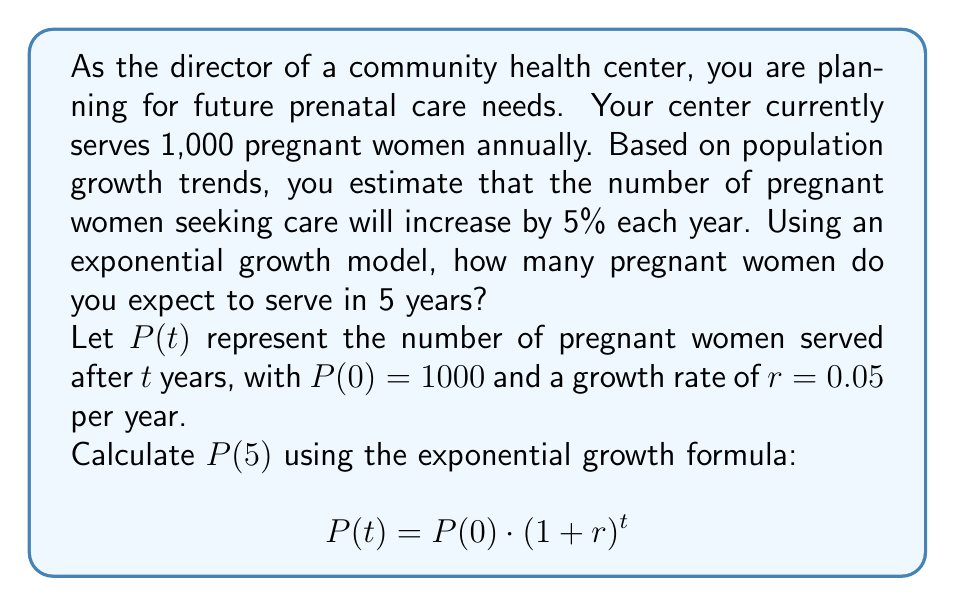Show me your answer to this math problem. To solve this problem, we'll use the exponential growth formula:

$$P(t) = P(0) \cdot (1 + r)^t$$

Where:
- $P(t)$ is the population after $t$ years
- $P(0)$ is the initial population
- $r$ is the growth rate (as a decimal)
- $t$ is the number of years

Given:
- $P(0) = 1000$ (initial number of pregnant women served)
- $r = 0.05$ (5% growth rate per year)
- $t = 5$ years

Let's plug these values into the formula:

$$\begin{align}
P(5) &= 1000 \cdot (1 + 0.05)^5 \\
&= 1000 \cdot (1.05)^5 \\
&= 1000 \cdot 1.2762815625 \\
&= 1276.2815625
\end{align}$$

Rounding to the nearest whole number (since we can't serve a fraction of a person), we get 1,276 pregnant women.
Answer: In 5 years, the community health center expects to serve approximately 1,276 pregnant women annually. 